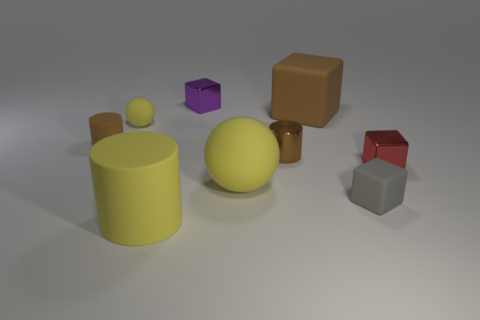Subtract all brown cylinders. How many cylinders are left? 1 Subtract 3 blocks. How many blocks are left? 1 Subtract all yellow cylinders. How many cylinders are left? 2 Add 1 rubber spheres. How many objects exist? 10 Subtract all balls. How many objects are left? 7 Subtract 0 red balls. How many objects are left? 9 Subtract all blue cylinders. Subtract all yellow spheres. How many cylinders are left? 3 Subtract all cyan spheres. How many yellow blocks are left? 0 Subtract all gray cubes. Subtract all cubes. How many objects are left? 4 Add 9 tiny purple things. How many tiny purple things are left? 10 